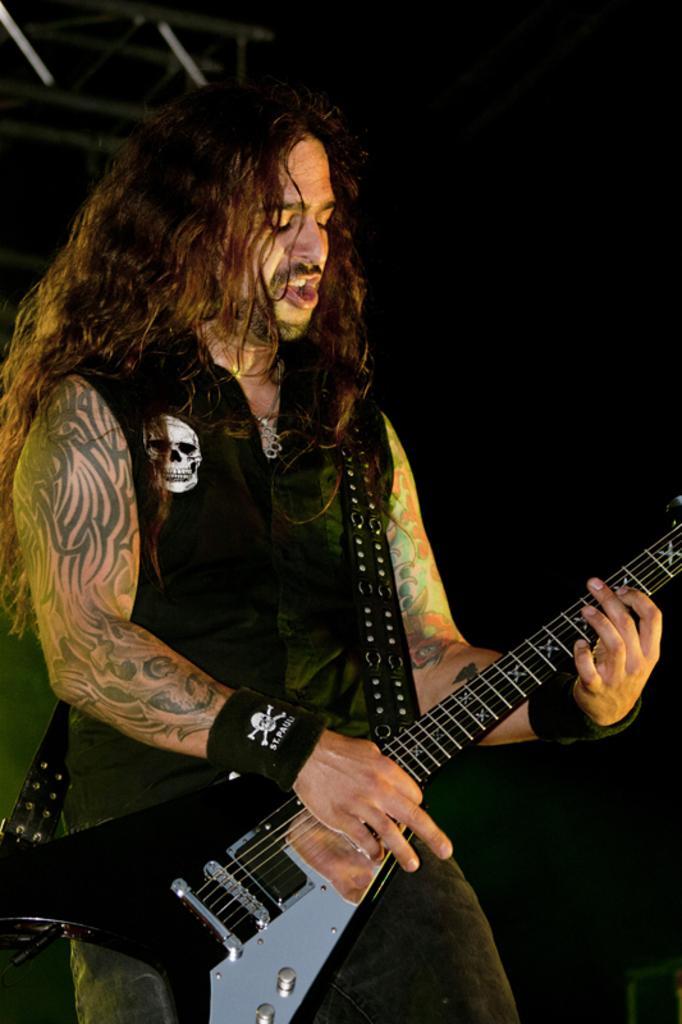Please provide a concise description of this image. In this image, we can see a man standing and holding a guitar. There is a dark background. 